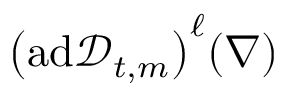<formula> <loc_0><loc_0><loc_500><loc_500>\left ( a d \ m a t h s c r { D } _ { t , m } \right ) ^ { \ell } ( \nabla )</formula> 